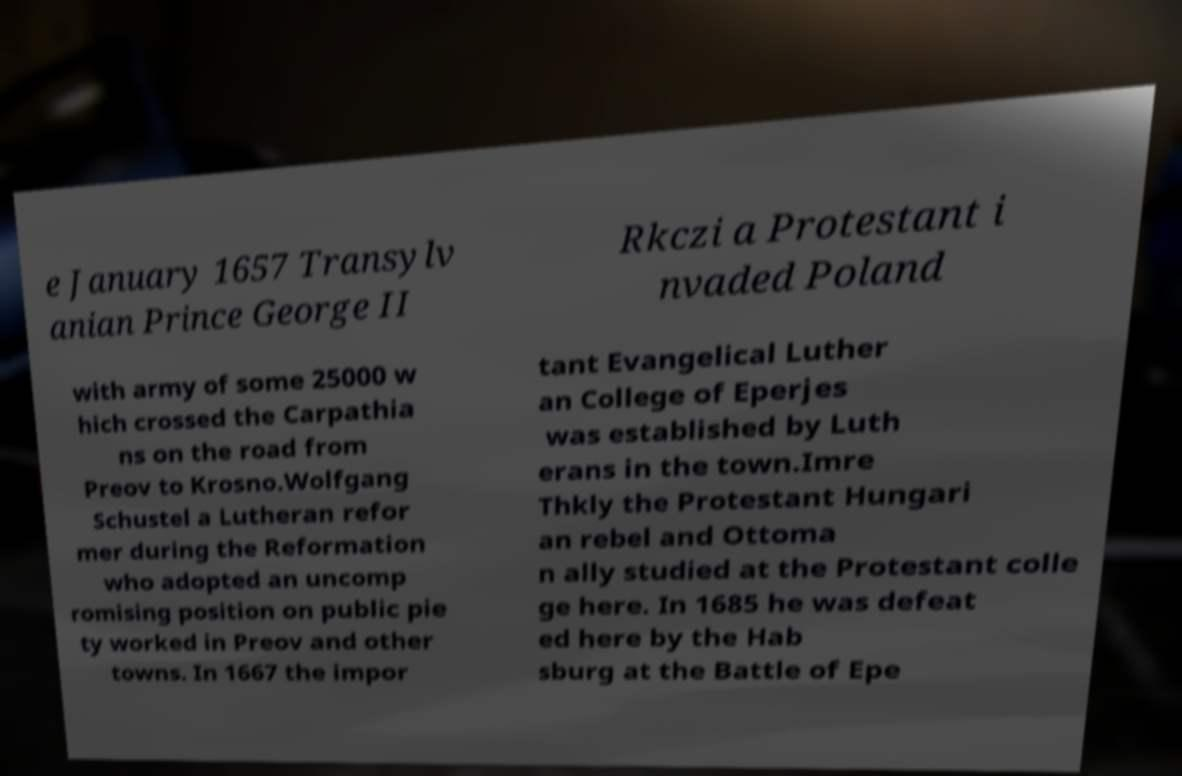Please identify and transcribe the text found in this image. e January 1657 Transylv anian Prince George II Rkczi a Protestant i nvaded Poland with army of some 25000 w hich crossed the Carpathia ns on the road from Preov to Krosno.Wolfgang Schustel a Lutheran refor mer during the Reformation who adopted an uncomp romising position on public pie ty worked in Preov and other towns. In 1667 the impor tant Evangelical Luther an College of Eperjes was established by Luth erans in the town.Imre Thkly the Protestant Hungari an rebel and Ottoma n ally studied at the Protestant colle ge here. In 1685 he was defeat ed here by the Hab sburg at the Battle of Epe 